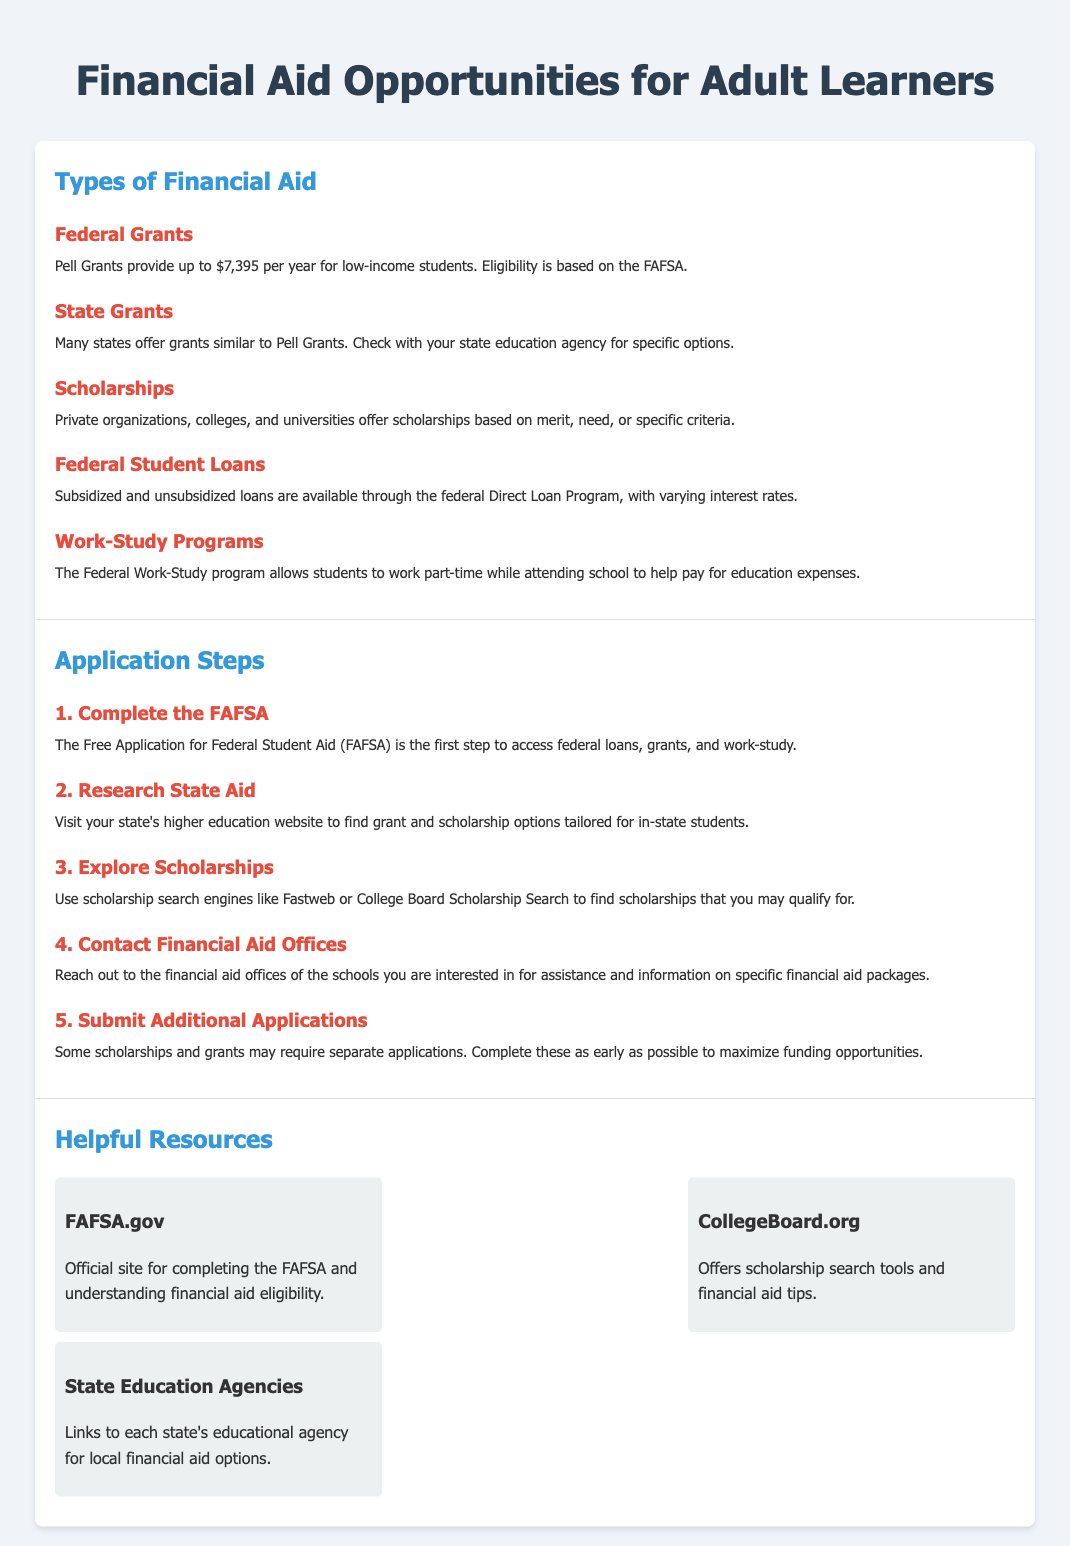What is the maximum Pell Grant amount? The document states that Pell Grants provide up to $7,395 per year for low-income students.
Answer: $7,395 What is the first step in the application process? The first step mentioned for the application process is to complete the FAFSA.
Answer: Complete the FAFSA What type of financial aid allows students to work part-time? The document explains that the Federal Work-Study program allows students to work part-time while attending school.
Answer: Work-Study Programs Which resource is the official site for completing the FAFSA? The document identifies FAFSA.gov as the official site for FAFSA completion.
Answer: FAFSA.gov What should you consult to find state-specific grant options? The document advises visiting your state's higher education website for grant and scholarship options.
Answer: State Education Agencies How many main types of financial aid are listed in the document? The document outlines five main types of financial aid opportunities.
Answer: Five What is the purpose of contacting financial aid offices? According to the document, contacting financial aid offices provides assistance and information on specific financial aid packages.
Answer: Assistance What search engines can be used to explore scholarships? The document mentions Fastweb and College Board Scholarship Search as scholarship search engines.
Answer: Fastweb or College Board What may require separate applications during the application process? The document notes that some scholarships and grants may require separate applications.
Answer: Scholarships and grants 